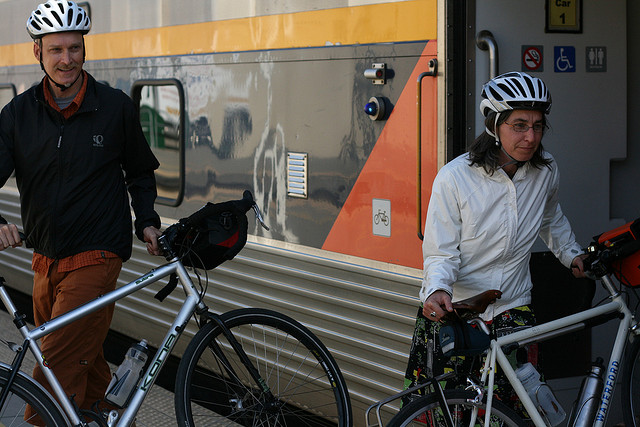Read and extract the text from this image. WATERFORD 